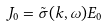<formula> <loc_0><loc_0><loc_500><loc_500>J _ { 0 } = \tilde { \sigma } ( k , \omega ) E _ { 0 }</formula> 